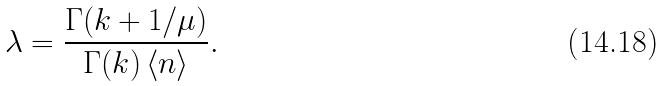Convert formula to latex. <formula><loc_0><loc_0><loc_500><loc_500>\lambda = \frac { \Gamma ( k + 1 / \mu ) } { \Gamma ( k ) \, \langle n \rangle } .</formula> 